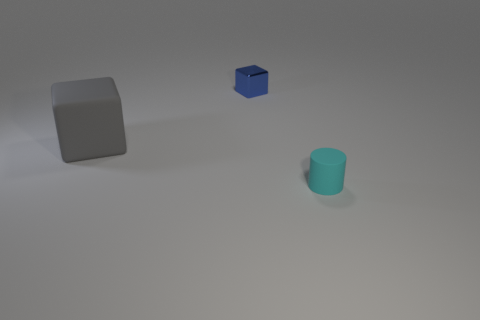There is a object that is on the left side of the tiny thing behind the tiny thing that is in front of the blue object; what shape is it?
Provide a succinct answer. Cube. Do the cube that is in front of the small blue metallic block and the tiny object behind the tiny cyan cylinder have the same material?
Provide a short and direct response. No. There is a gray thing that is the same shape as the blue thing; what is it made of?
Offer a very short reply. Rubber. Are there any other things that are the same size as the gray rubber block?
Give a very brief answer. No. There is a tiny thing that is behind the cyan object; is it the same shape as the object on the left side of the tiny blue block?
Provide a succinct answer. Yes. Is the number of gray rubber things that are behind the big matte block less than the number of cubes to the left of the tiny cyan rubber cylinder?
Give a very brief answer. Yes. What number of other things are the same shape as the metallic object?
Keep it short and to the point. 1. There is a tiny thing that is the same material as the gray block; what shape is it?
Your response must be concise. Cylinder. What color is the thing that is behind the tiny cylinder and on the right side of the matte block?
Make the answer very short. Blue. Does the tiny object behind the small cyan thing have the same material as the small cyan cylinder?
Give a very brief answer. No. 